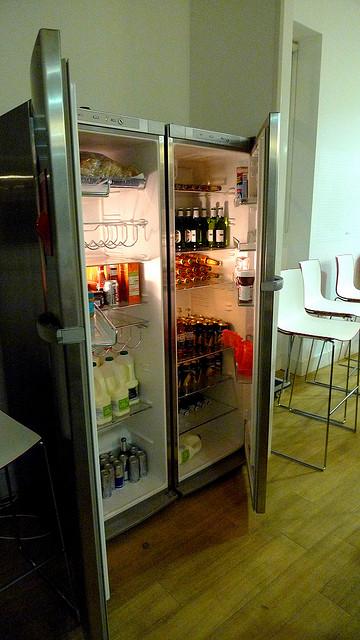Why is the door open in the fridge?
Be succinct. To see inside. Is there beer in the fridge?
Be succinct. Yes. How many doors do you see?
Concise answer only. 2. Is this room messy?
Be succinct. No. 